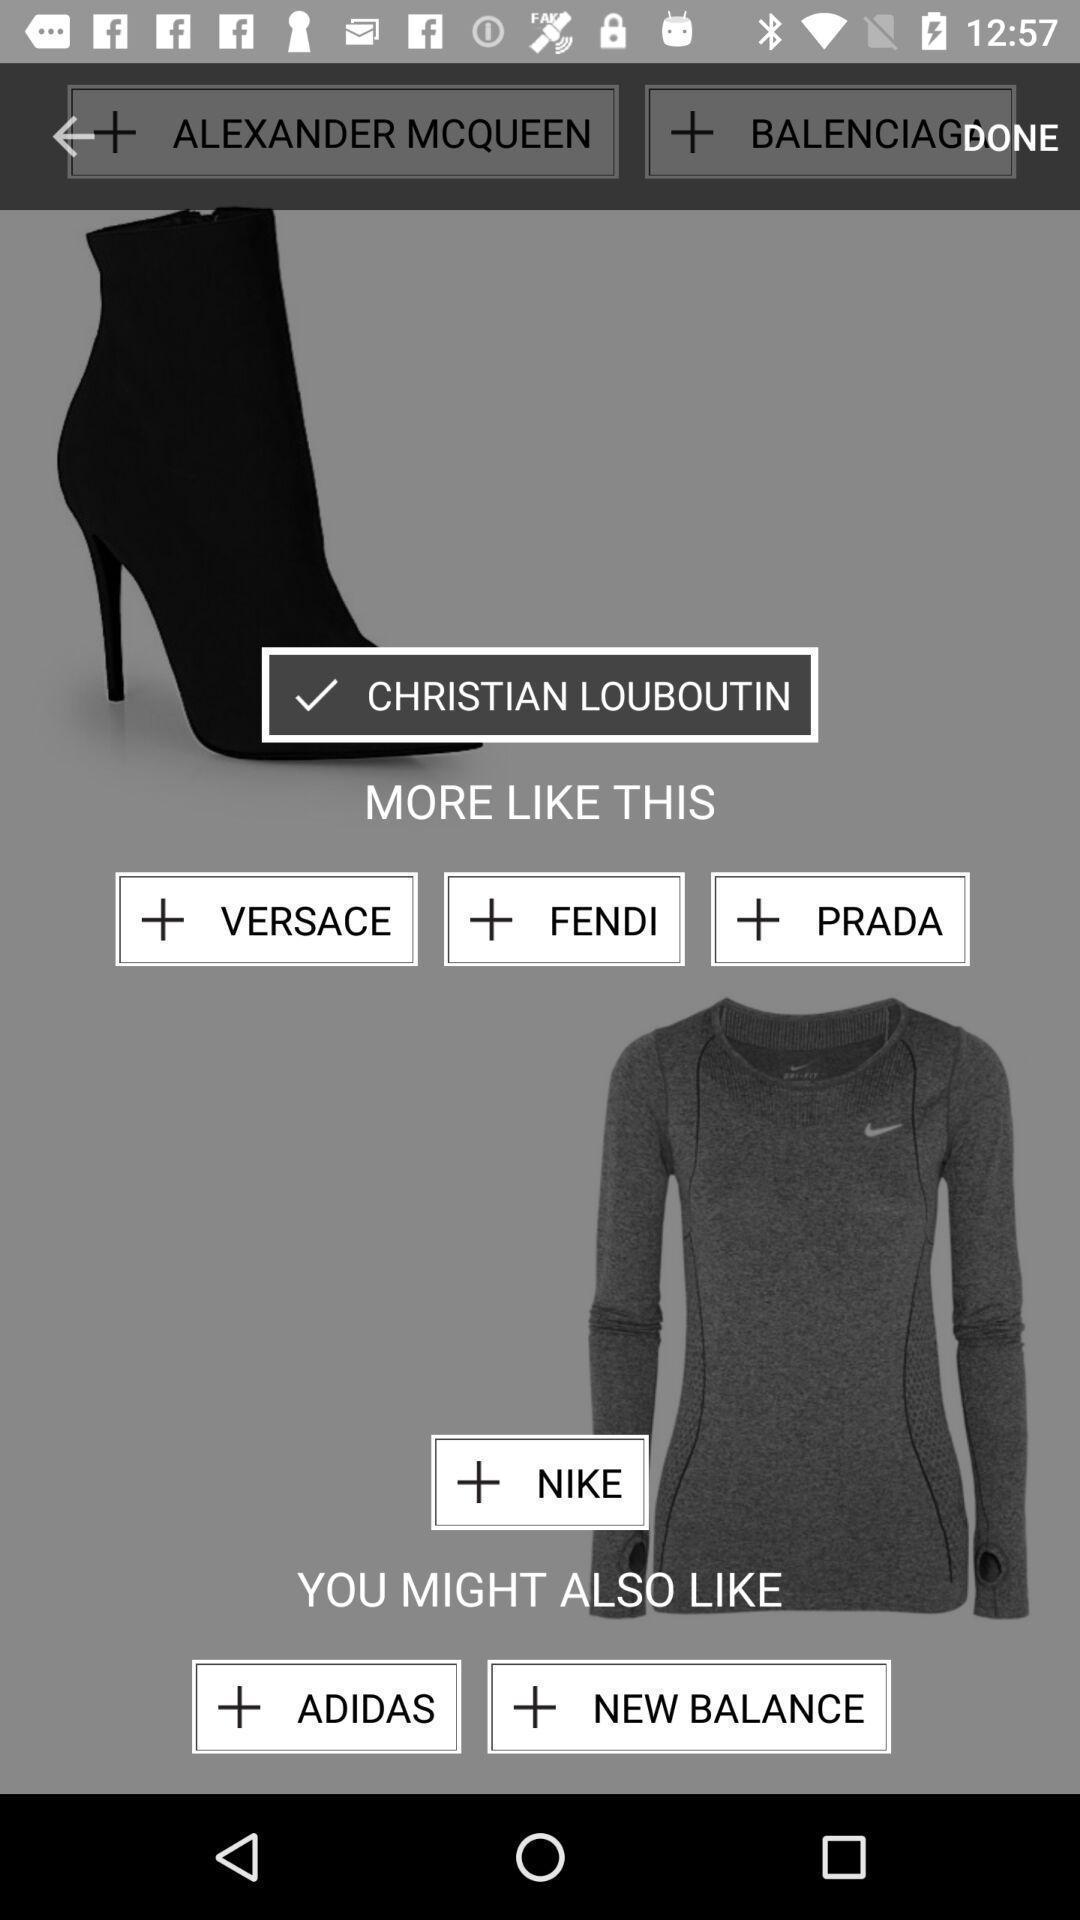Please provide a description for this image. Various clothing filters displayed of a online shopping app. 